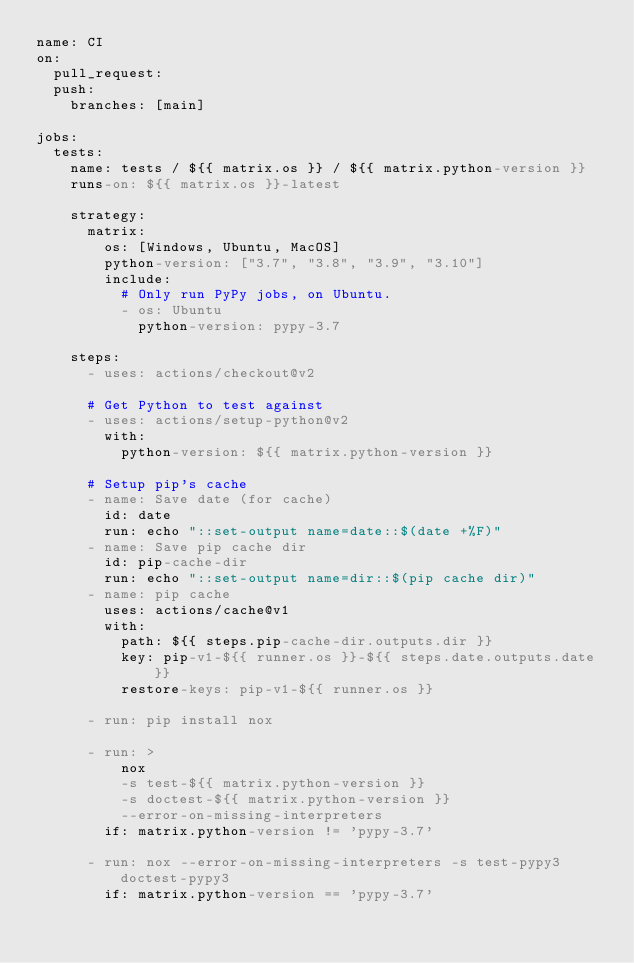<code> <loc_0><loc_0><loc_500><loc_500><_YAML_>name: CI
on:
  pull_request:
  push:
    branches: [main]

jobs:
  tests:
    name: tests / ${{ matrix.os }} / ${{ matrix.python-version }}
    runs-on: ${{ matrix.os }}-latest

    strategy:
      matrix:
        os: [Windows, Ubuntu, MacOS]
        python-version: ["3.7", "3.8", "3.9", "3.10"]
        include:
          # Only run PyPy jobs, on Ubuntu.
          - os: Ubuntu
            python-version: pypy-3.7

    steps:
      - uses: actions/checkout@v2

      # Get Python to test against
      - uses: actions/setup-python@v2
        with:
          python-version: ${{ matrix.python-version }}

      # Setup pip's cache
      - name: Save date (for cache)
        id: date
        run: echo "::set-output name=date::$(date +%F)"
      - name: Save pip cache dir
        id: pip-cache-dir
        run: echo "::set-output name=dir::$(pip cache dir)"
      - name: pip cache
        uses: actions/cache@v1
        with:
          path: ${{ steps.pip-cache-dir.outputs.dir }}
          key: pip-v1-${{ runner.os }}-${{ steps.date.outputs.date }}
          restore-keys: pip-v1-${{ runner.os }}

      - run: pip install nox

      - run: >
          nox
          -s test-${{ matrix.python-version }}
          -s doctest-${{ matrix.python-version }}
          --error-on-missing-interpreters
        if: matrix.python-version != 'pypy-3.7'

      - run: nox --error-on-missing-interpreters -s test-pypy3 doctest-pypy3
        if: matrix.python-version == 'pypy-3.7'
</code> 